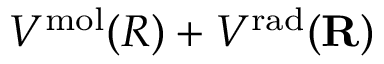Convert formula to latex. <formula><loc_0><loc_0><loc_500><loc_500>V ^ { m o l } ( R ) + V ^ { r a d } ( { R } )</formula> 